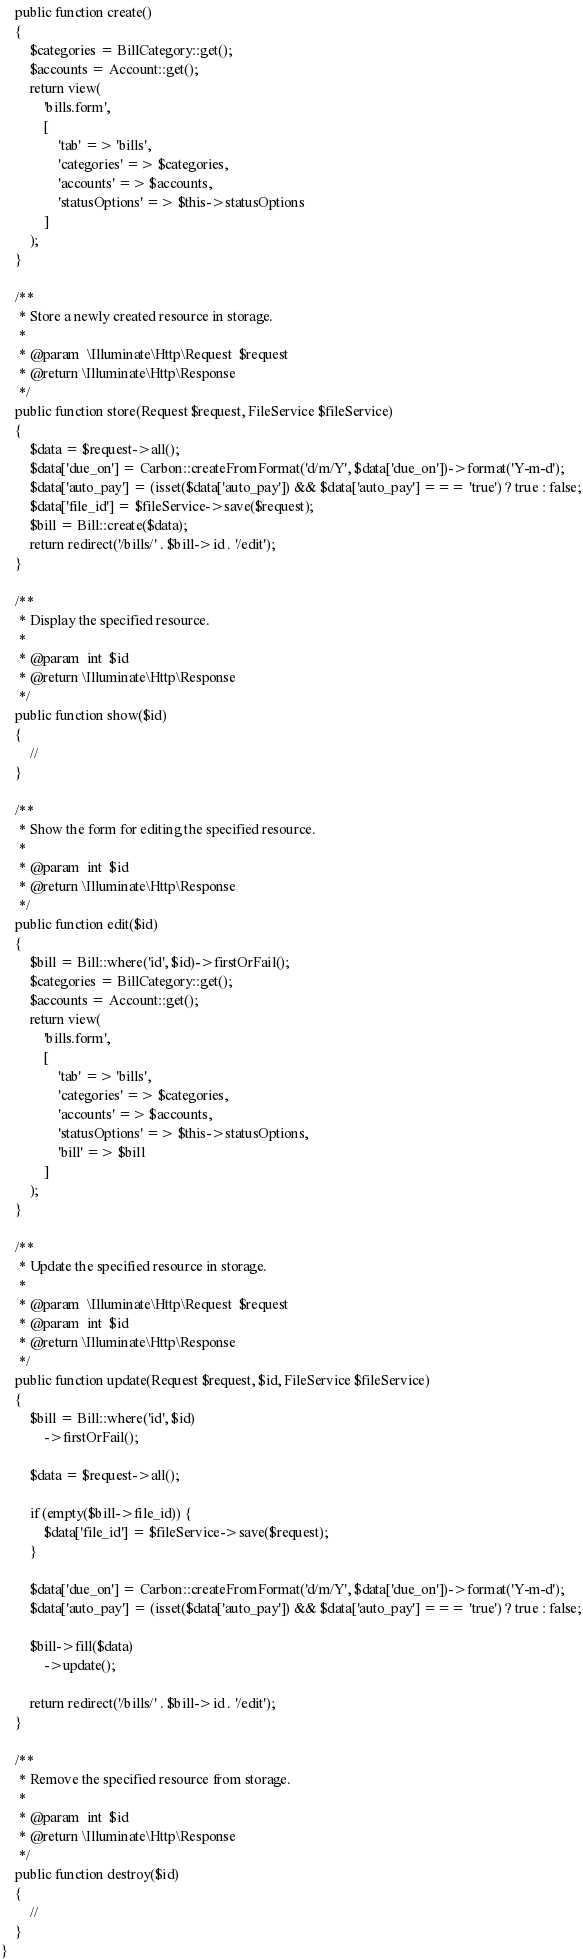Convert code to text. <code><loc_0><loc_0><loc_500><loc_500><_PHP_>    public function create()
    {
        $categories = BillCategory::get();
        $accounts = Account::get();
        return view(
            'bills.form',
            [
                'tab' => 'bills',
                'categories' => $categories,
                'accounts' => $accounts,
                'statusOptions' => $this->statusOptions
            ]
        );
    }

    /**
     * Store a newly created resource in storage.
     *
     * @param  \Illuminate\Http\Request  $request
     * @return \Illuminate\Http\Response
     */
    public function store(Request $request, FileService $fileService)
    {
        $data = $request->all();
        $data['due_on'] = Carbon::createFromFormat('d/m/Y', $data['due_on'])->format('Y-m-d');
        $data['auto_pay'] = (isset($data['auto_pay']) && $data['auto_pay'] === 'true') ? true : false;
        $data['file_id'] = $fileService->save($request);
        $bill = Bill::create($data);
        return redirect('/bills/' . $bill->id . '/edit');
    }

    /**
     * Display the specified resource.
     *
     * @param  int  $id
     * @return \Illuminate\Http\Response
     */
    public function show($id)
    {
        //
    }

    /**
     * Show the form for editing the specified resource.
     *
     * @param  int  $id
     * @return \Illuminate\Http\Response
     */
    public function edit($id)
    {
        $bill = Bill::where('id', $id)->firstOrFail();
        $categories = BillCategory::get();
        $accounts = Account::get();
        return view(
            'bills.form',
            [
                'tab' => 'bills',
                'categories' => $categories,
                'accounts' => $accounts,
                'statusOptions' => $this->statusOptions,
                'bill' => $bill
            ]
        );
    }

    /**
     * Update the specified resource in storage.
     *
     * @param  \Illuminate\Http\Request  $request
     * @param  int  $id
     * @return \Illuminate\Http\Response
     */
    public function update(Request $request, $id, FileService $fileService)
    {
        $bill = Bill::where('id', $id)
            ->firstOrFail();

        $data = $request->all();

        if (empty($bill->file_id)) {
            $data['file_id'] = $fileService->save($request);
        }

        $data['due_on'] = Carbon::createFromFormat('d/m/Y', $data['due_on'])->format('Y-m-d');
        $data['auto_pay'] = (isset($data['auto_pay']) && $data['auto_pay'] === 'true') ? true : false;

        $bill->fill($data)
            ->update();

        return redirect('/bills/' . $bill->id . '/edit');
    }

    /**
     * Remove the specified resource from storage.
     *
     * @param  int  $id
     * @return \Illuminate\Http\Response
     */
    public function destroy($id)
    {
        //
    }
}
</code> 